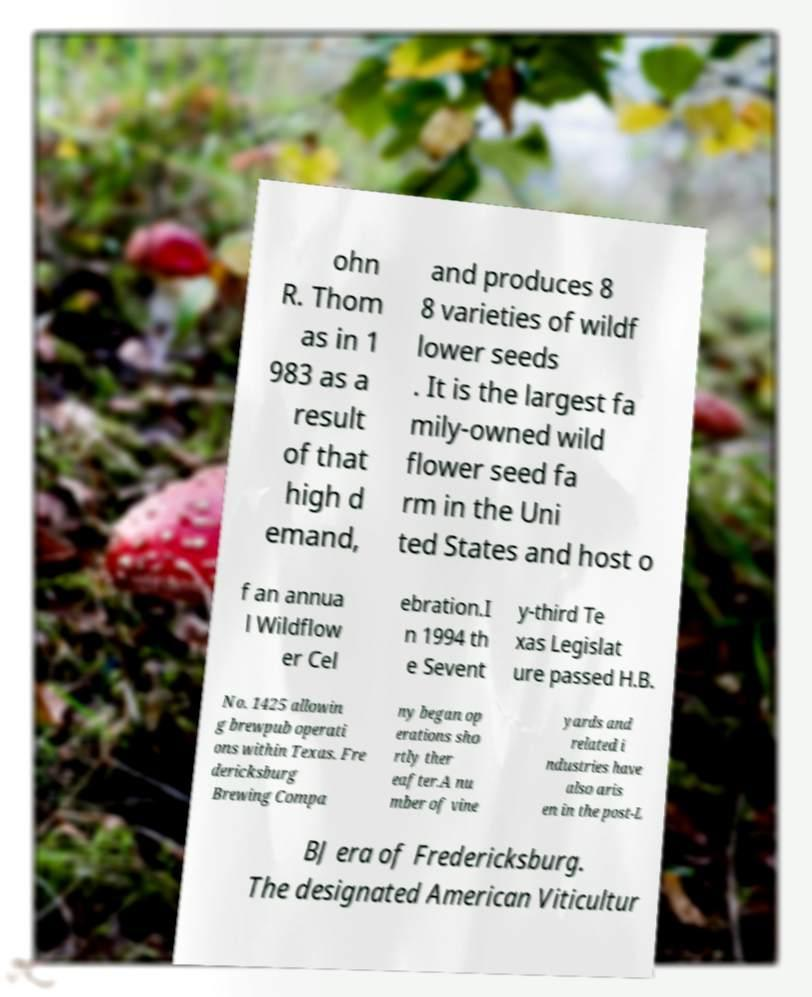There's text embedded in this image that I need extracted. Can you transcribe it verbatim? ohn R. Thom as in 1 983 as a result of that high d emand, and produces 8 8 varieties of wildf lower seeds . It is the largest fa mily-owned wild flower seed fa rm in the Uni ted States and host o f an annua l Wildflow er Cel ebration.I n 1994 th e Sevent y-third Te xas Legislat ure passed H.B. No. 1425 allowin g brewpub operati ons within Texas. Fre dericksburg Brewing Compa ny began op erations sho rtly ther eafter.A nu mber of vine yards and related i ndustries have also aris en in the post-L BJ era of Fredericksburg. The designated American Viticultur 